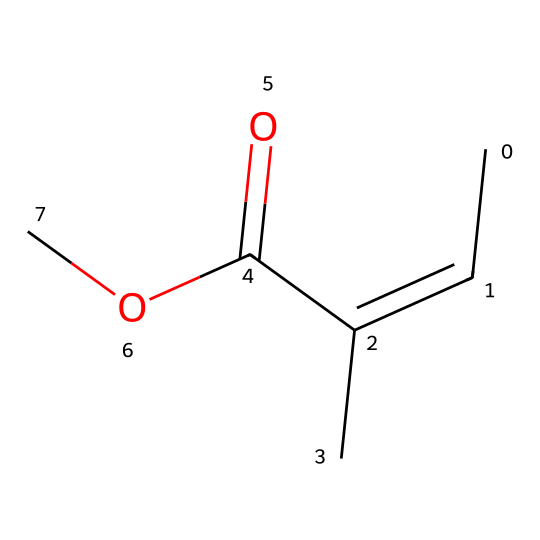how many carbon atoms are present in this chemical? The SMILES representation CC=C(C)C(=O)OC shows that there are five carbon (C) atoms. Each C corresponds to a 'C' in the text.
Answer: five what is the functional group present in this chemical? The chemical features an ester functional group, indicated by the presence of the -O-C(=O) part in the structure.
Answer: ester isomerism present in this chemical structure? The presence of a double bond (C=C) in the formula suggests that E-Z isomerism is possible due to the restricted rotation around the double bond.
Answer: yes how many hydrogen atoms are attached to the carbon skeleton? Each carbon usually bonds with enough hydrogen atoms to make four total bonds. Analyzing the structure, there are eight hydrogen atoms attached to the carbon skeleton.
Answer: eight what type of isomers are possible for this structure? Given the presence of a double bond between two carbon atoms, the type of isomerism possible here is geometric isomerism, specifically E-Z isomerism.
Answer: E-Z isomerism which part of the chemical contributes to its solvency in varnishes? The ester functional group (C(=O)OC) in this chemical contributes to increased solvency in varnishes due to its polar nature, allowing it to dissolve in nonpolar solvents.
Answer: ester 